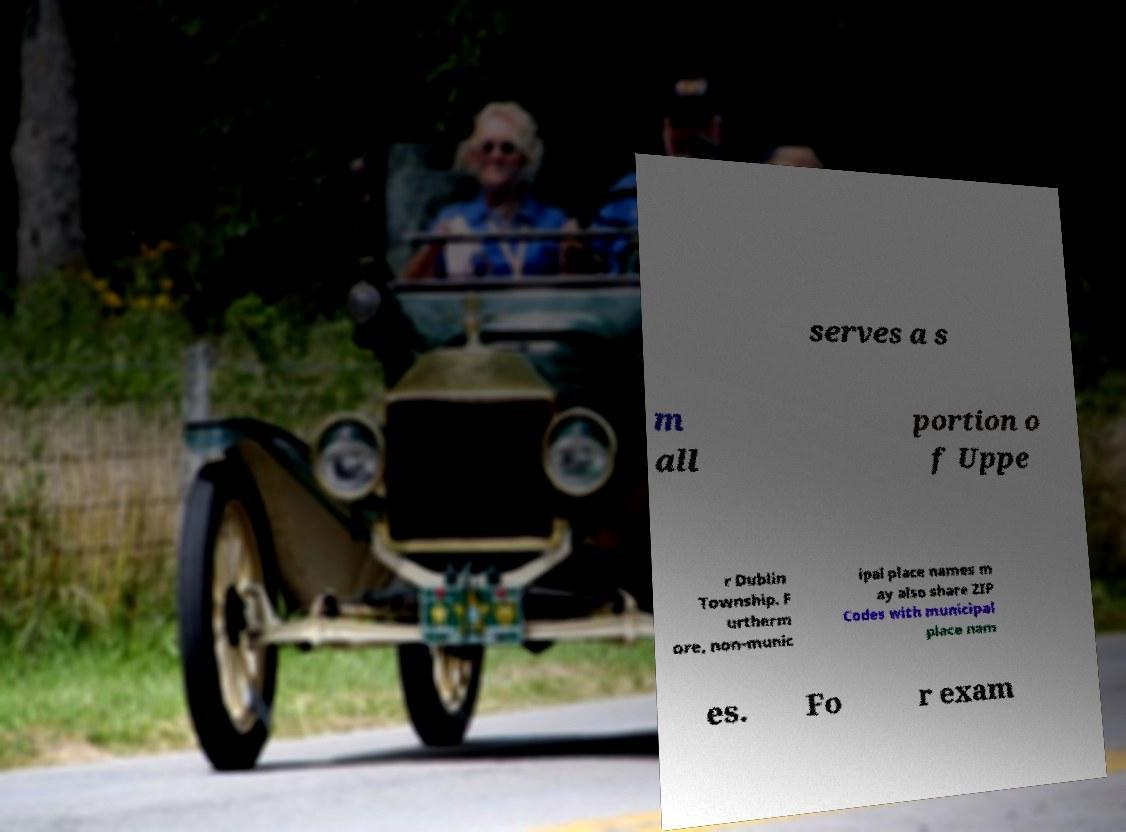Could you assist in decoding the text presented in this image and type it out clearly? serves a s m all portion o f Uppe r Dublin Township. F urtherm ore, non-munic ipal place names m ay also share ZIP Codes with municipal place nam es. Fo r exam 